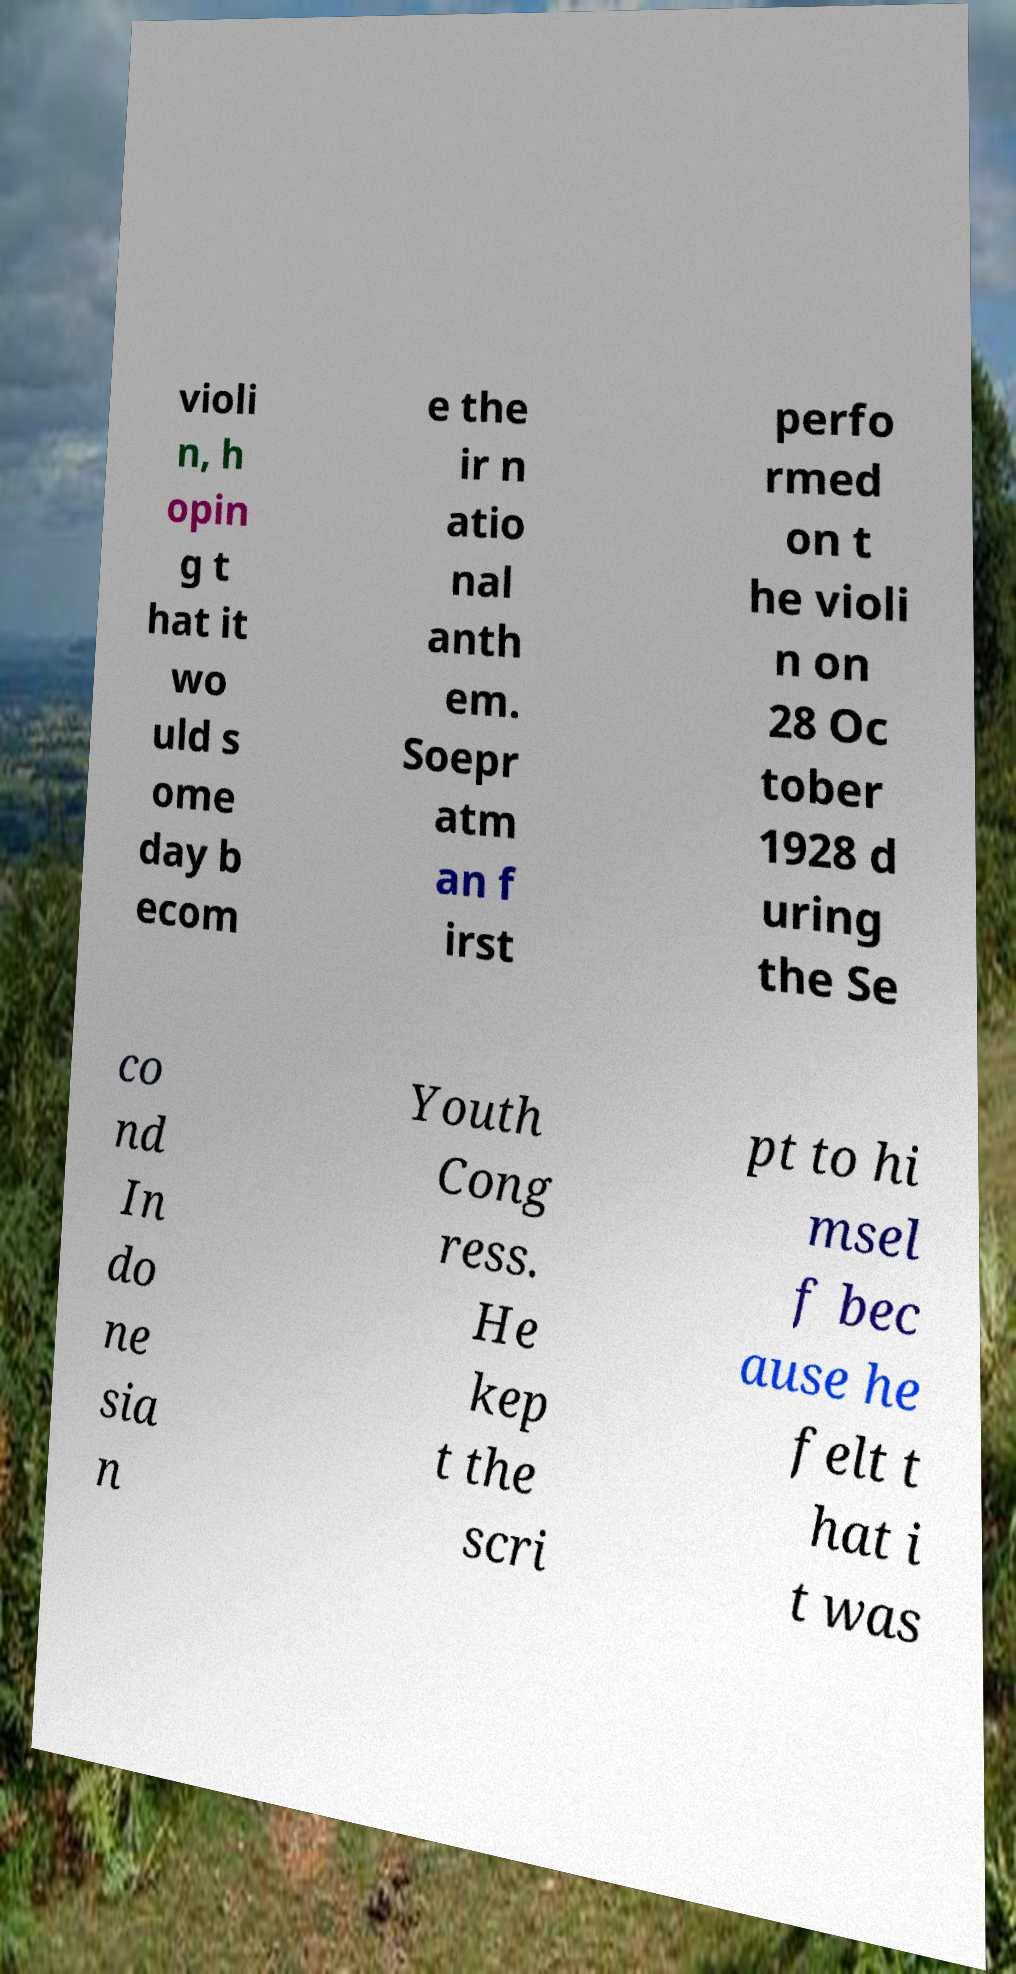I need the written content from this picture converted into text. Can you do that? violi n, h opin g t hat it wo uld s ome day b ecom e the ir n atio nal anth em. Soepr atm an f irst perfo rmed on t he violi n on 28 Oc tober 1928 d uring the Se co nd In do ne sia n Youth Cong ress. He kep t the scri pt to hi msel f bec ause he felt t hat i t was 